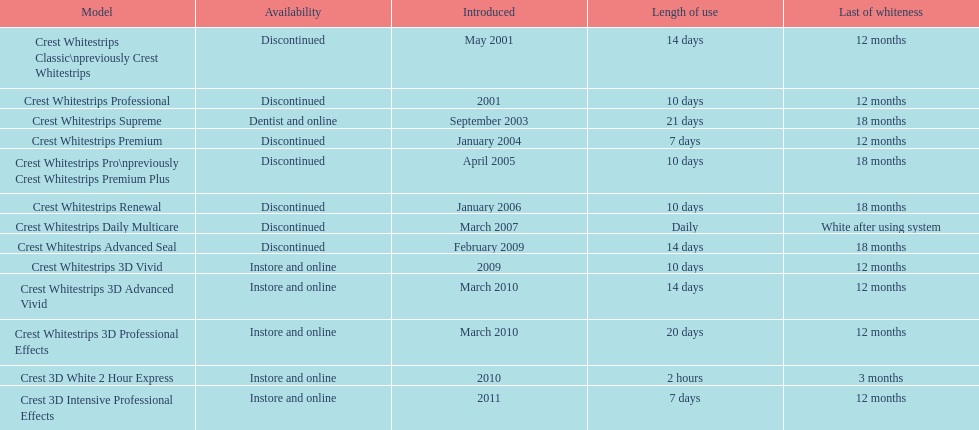Which discontinued item was presented in the same year as crest whitestrips 3d vivid? Crest Whitestrips Advanced Seal. 